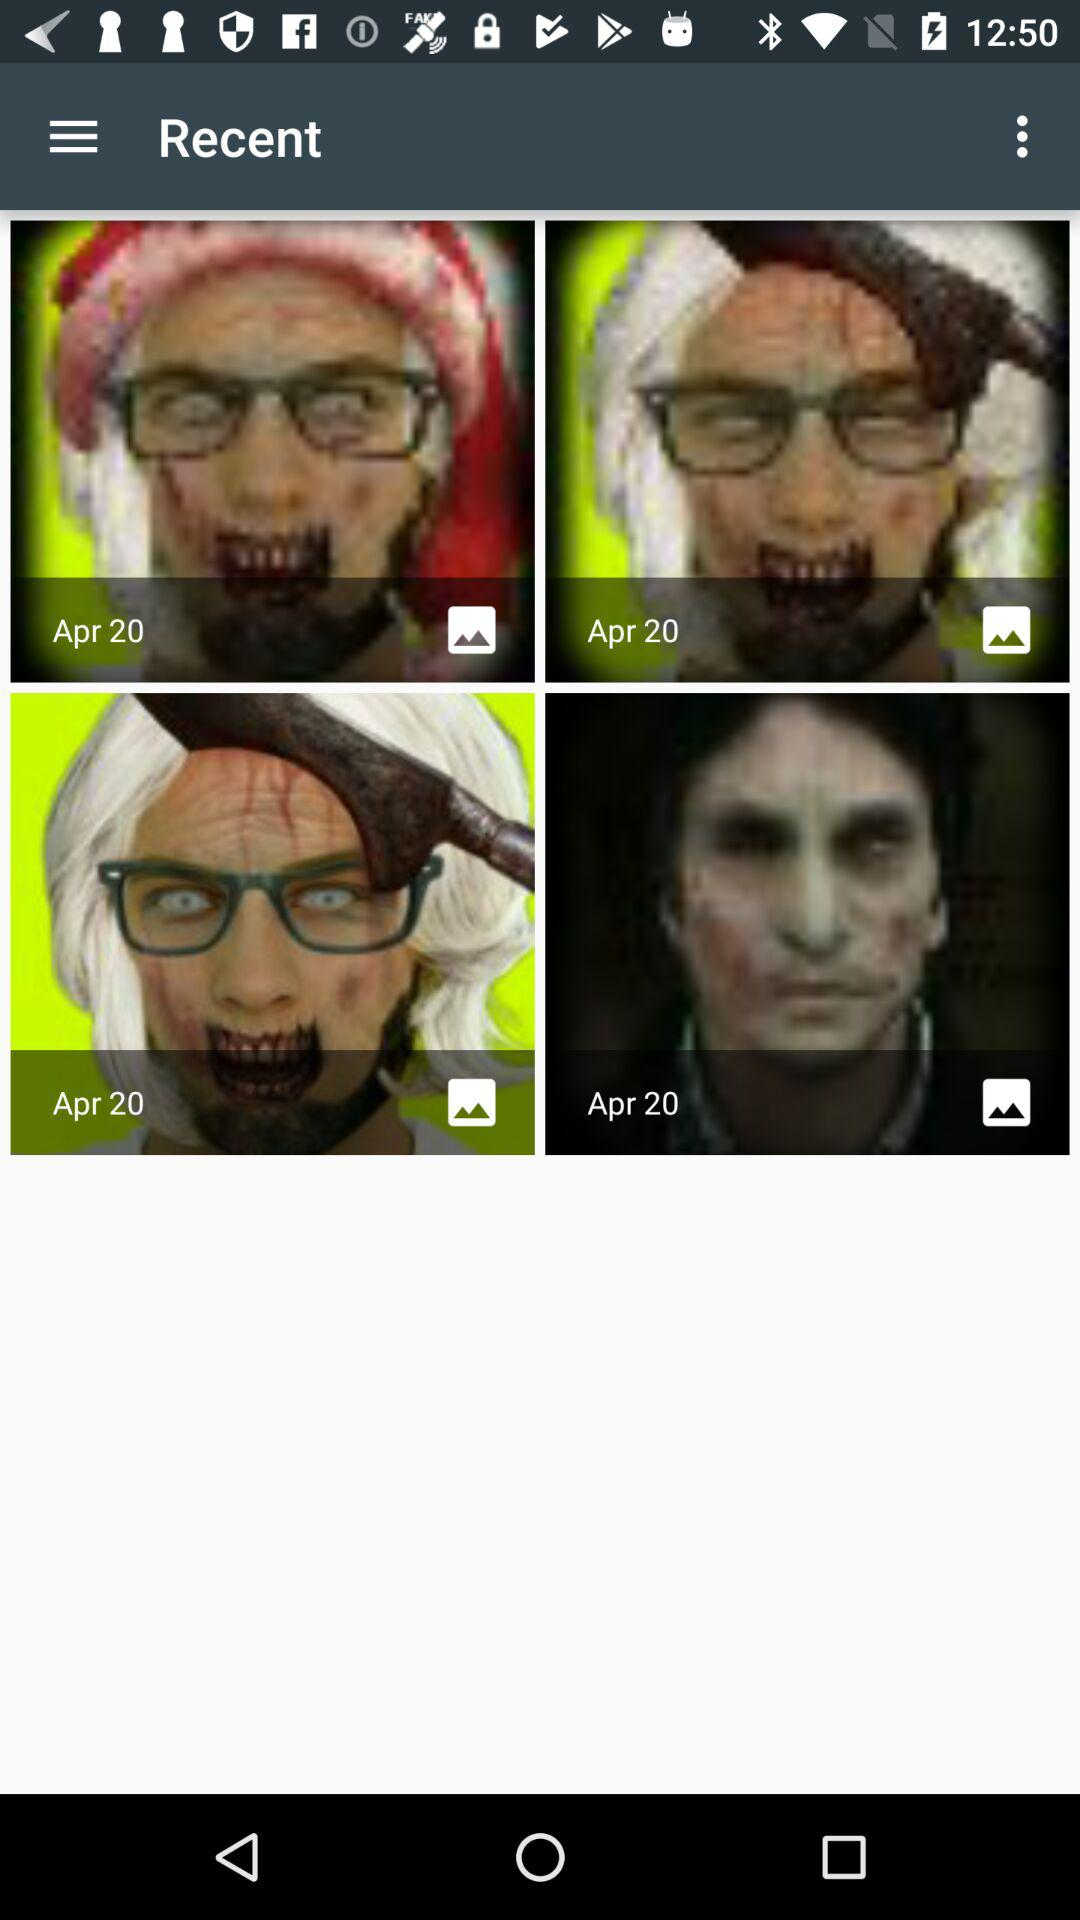What is the mentioned date on the images? The mentioned date is April 20. 